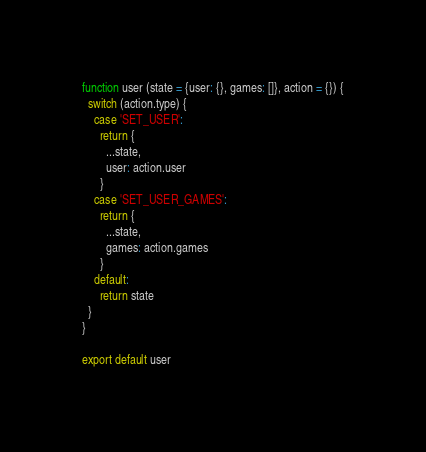Convert code to text. <code><loc_0><loc_0><loc_500><loc_500><_JavaScript_>function user (state = {user: {}, games: []}, action = {}) {
  switch (action.type) {
    case 'SET_USER':
      return {
        ...state,
        user: action.user
      }
    case 'SET_USER_GAMES':
      return {
        ...state,
        games: action.games
      }
    default:
      return state
  }
}

export default user
</code> 